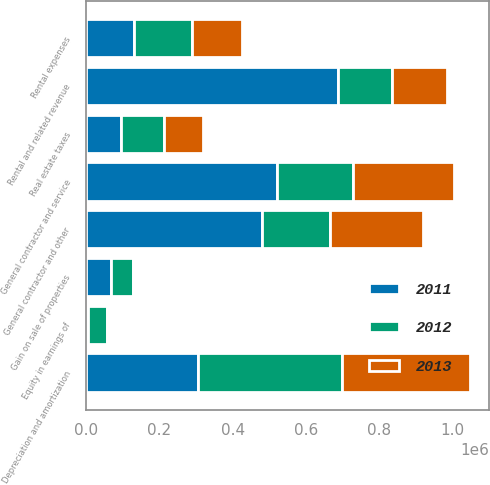Convert chart to OTSL. <chart><loc_0><loc_0><loc_500><loc_500><stacked_bar_chart><ecel><fcel>Rental and related revenue<fcel>General contractor and service<fcel>Rental expenses<fcel>Real estate taxes<fcel>General contractor and other<fcel>Depreciation and amortization<fcel>Equity in earnings of<fcel>Gain on sale of properties<nl><fcel>2012<fcel>148402<fcel>206596<fcel>159008<fcel>117747<fcel>183833<fcel>393450<fcel>54116<fcel>59179<nl><fcel>2013<fcel>148402<fcel>275071<fcel>137797<fcel>106128<fcel>254870<fcel>349015<fcel>4674<fcel>344<nl><fcel>2011<fcel>686242<fcel>521796<fcel>129717<fcel>95666<fcel>480480<fcel>305070<fcel>4565<fcel>68549<nl></chart> 